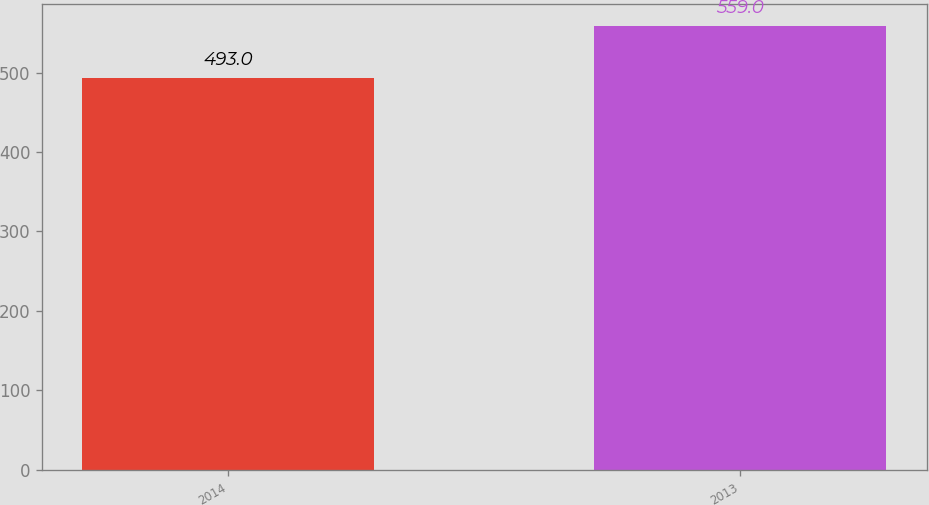Convert chart to OTSL. <chart><loc_0><loc_0><loc_500><loc_500><bar_chart><fcel>2014<fcel>2013<nl><fcel>493<fcel>559<nl></chart> 